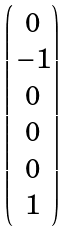Convert formula to latex. <formula><loc_0><loc_0><loc_500><loc_500>\begin{pmatrix} 0 \\ \, - 1 \\ 0 \\ 0 \\ 0 \\ 1 \end{pmatrix}</formula> 